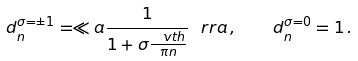Convert formula to latex. <formula><loc_0><loc_0><loc_500><loc_500>d _ { n } ^ { \sigma = \pm 1 } = \ll a \frac { 1 } { 1 + \sigma \frac { \ v t h } { \pi n } } \ r r a \, , \quad d _ { n } ^ { \sigma = 0 } = 1 \, .</formula> 